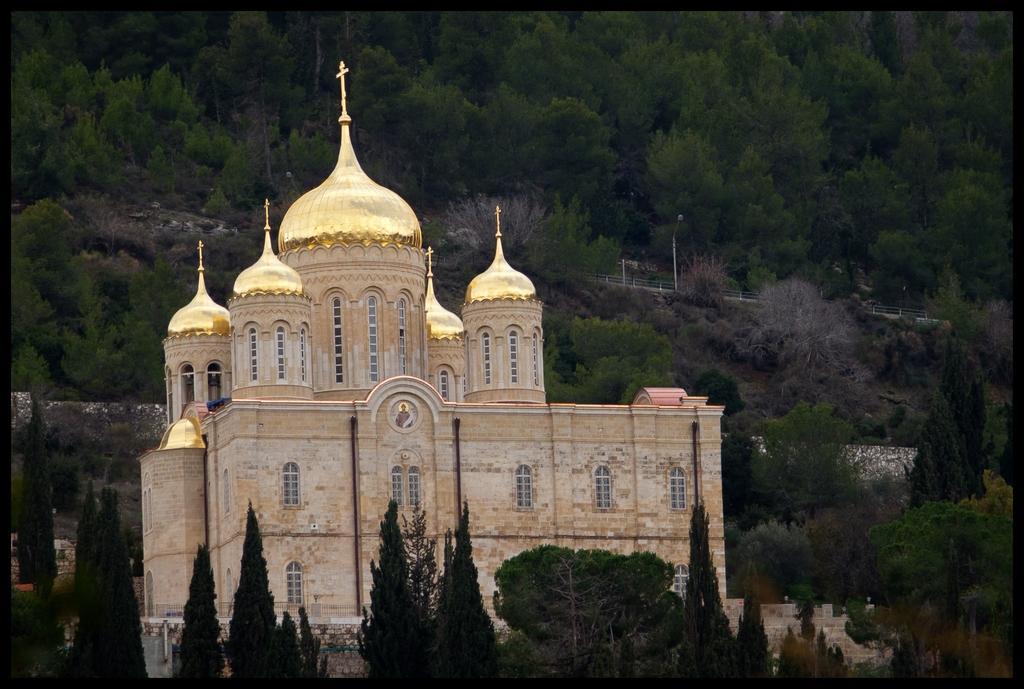Please provide a concise description of this image. In this picture there is a beautiful brown color church in the middle of the image. On the top there is a golden domes. Behind there are many trees on the hill. 